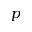<formula> <loc_0><loc_0><loc_500><loc_500>p</formula> 